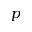<formula> <loc_0><loc_0><loc_500><loc_500>p</formula> 